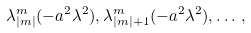<formula> <loc_0><loc_0><loc_500><loc_500>\lambda ^ { m } _ { | m | } ( - a ^ { 2 } \lambda ^ { 2 } ) , \lambda ^ { m } _ { | m | + 1 } ( - a ^ { 2 } \lambda ^ { 2 } ) , \dots \, ,</formula> 